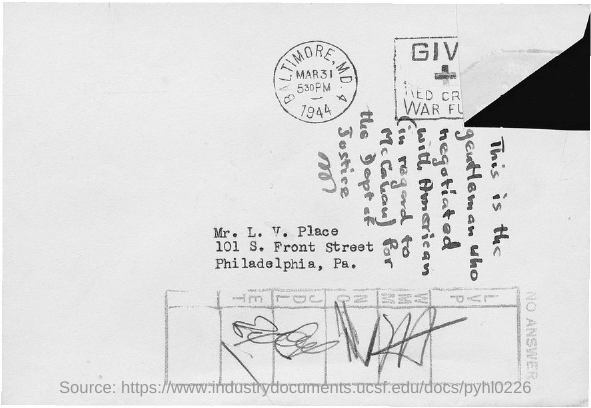What is the name of the person given in the address?
Ensure brevity in your answer.  Mr. L. V. Place. 